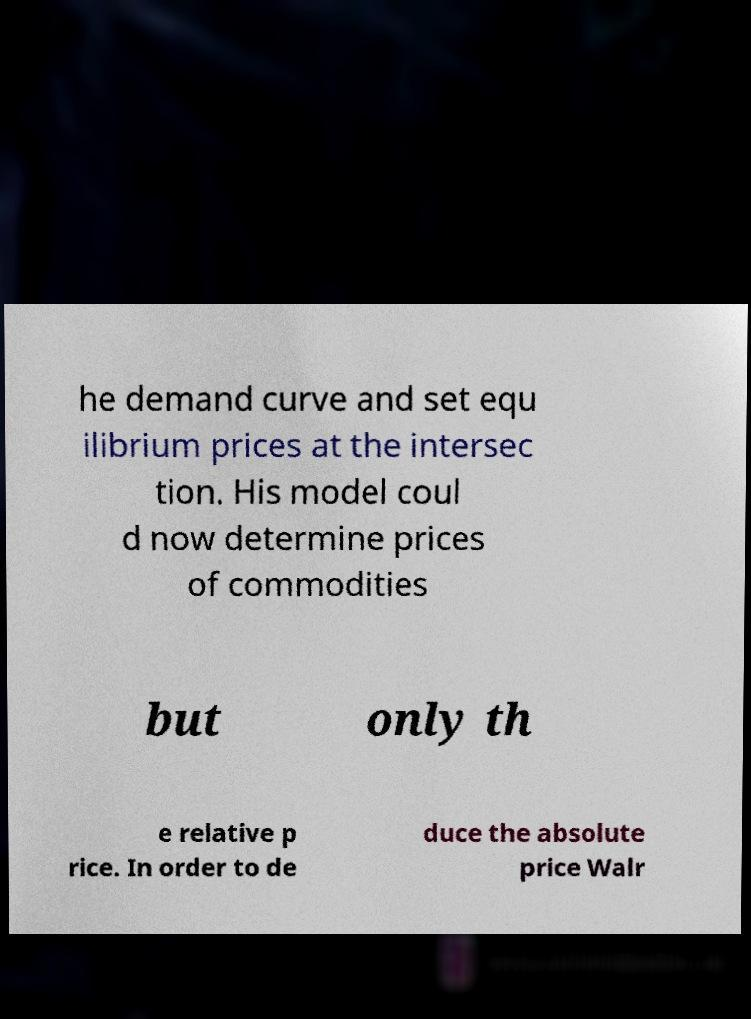Could you extract and type out the text from this image? he demand curve and set equ ilibrium prices at the intersec tion. His model coul d now determine prices of commodities but only th e relative p rice. In order to de duce the absolute price Walr 